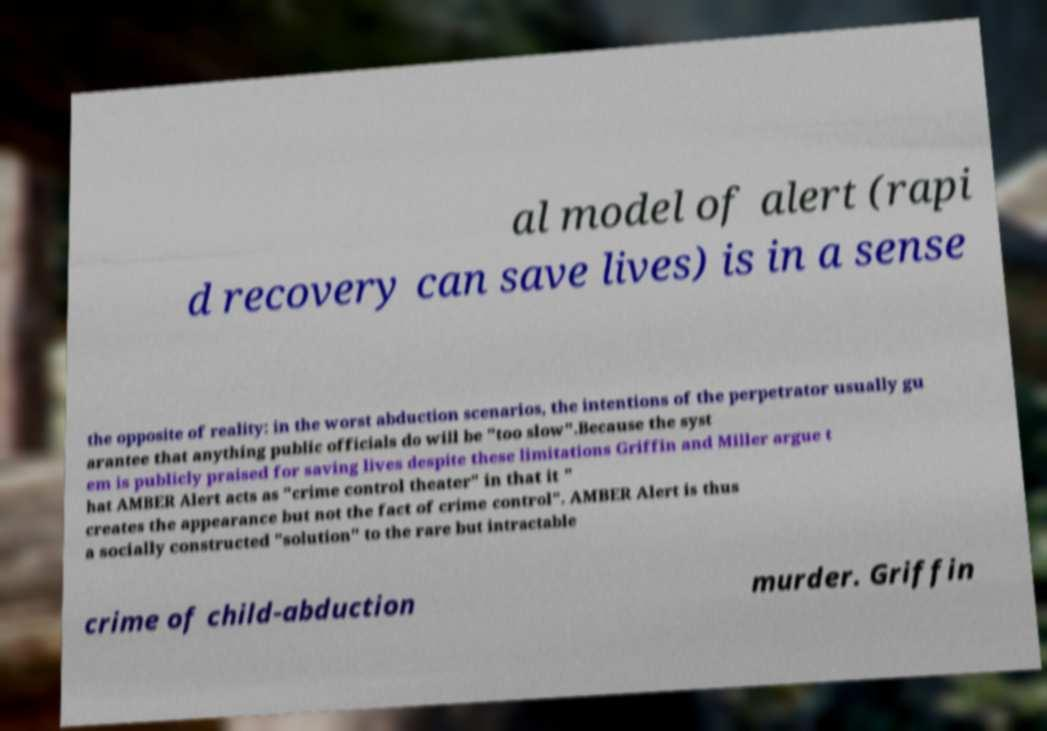What messages or text are displayed in this image? I need them in a readable, typed format. al model of alert (rapi d recovery can save lives) is in a sense the opposite of reality: in the worst abduction scenarios, the intentions of the perpetrator usually gu arantee that anything public officials do will be "too slow".Because the syst em is publicly praised for saving lives despite these limitations Griffin and Miller argue t hat AMBER Alert acts as "crime control theater" in that it " creates the appearance but not the fact of crime control". AMBER Alert is thus a socially constructed "solution" to the rare but intractable crime of child-abduction murder. Griffin 